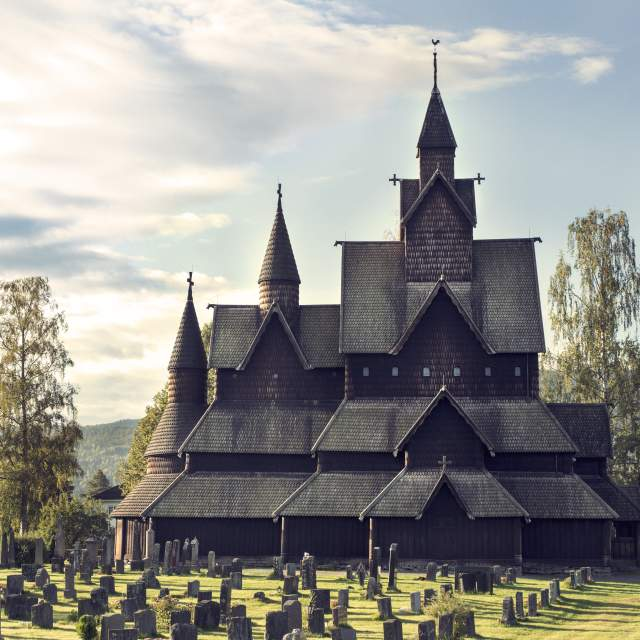What kind of events or ceremonies might take place at this church? As an active parish church, Heddal Stave Church hosts a variety of events and ceremonies throughout the year. These include regular Sunday services, weddings, baptisms, and traditional Norwegian festivals. The church's historical ambiance makes it a popular venue for cultural and religious events, attracting locals and tourists who appreciate its rich heritage and serene beauty. Special ceremonies, such as Christmas and Easter services, are particularly significant, drawing larger congregations to celebrate in this historical and spiritually uplifting setting. 